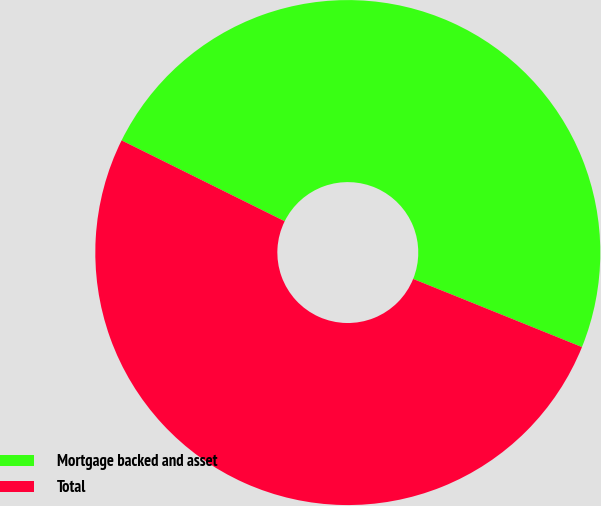<chart> <loc_0><loc_0><loc_500><loc_500><pie_chart><fcel>Mortgage backed and asset<fcel>Total<nl><fcel>48.78%<fcel>51.22%<nl></chart> 